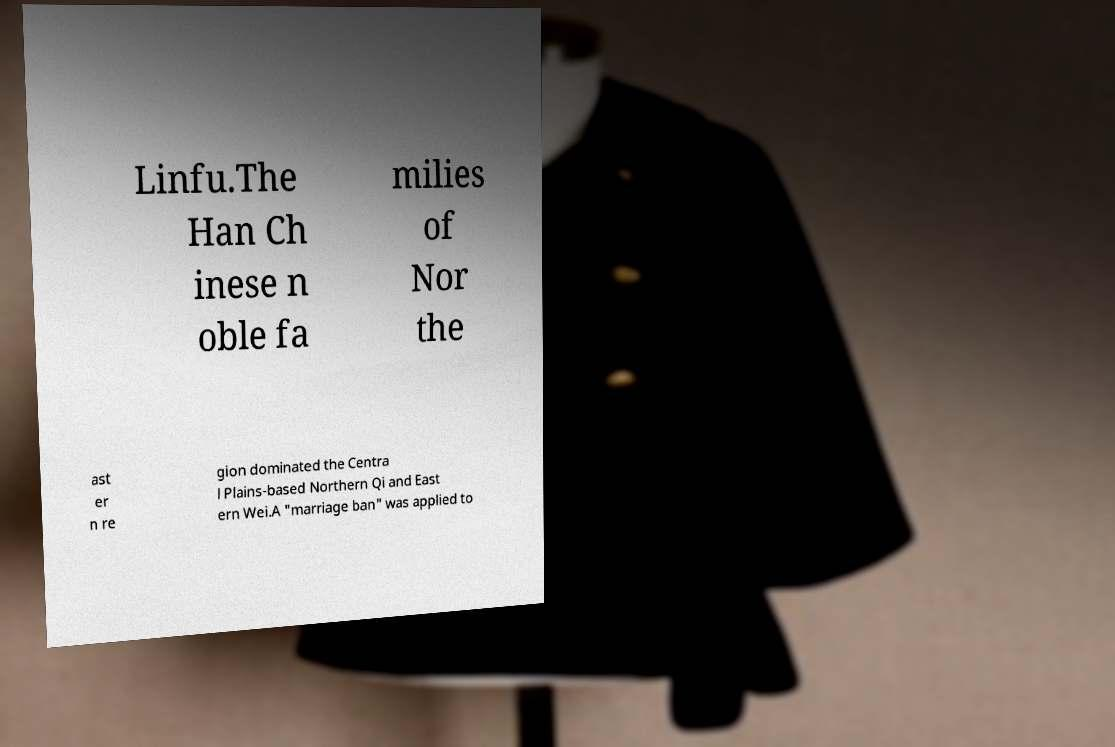Please identify and transcribe the text found in this image. Linfu.The Han Ch inese n oble fa milies of Nor the ast er n re gion dominated the Centra l Plains-based Northern Qi and East ern Wei.A "marriage ban" was applied to 